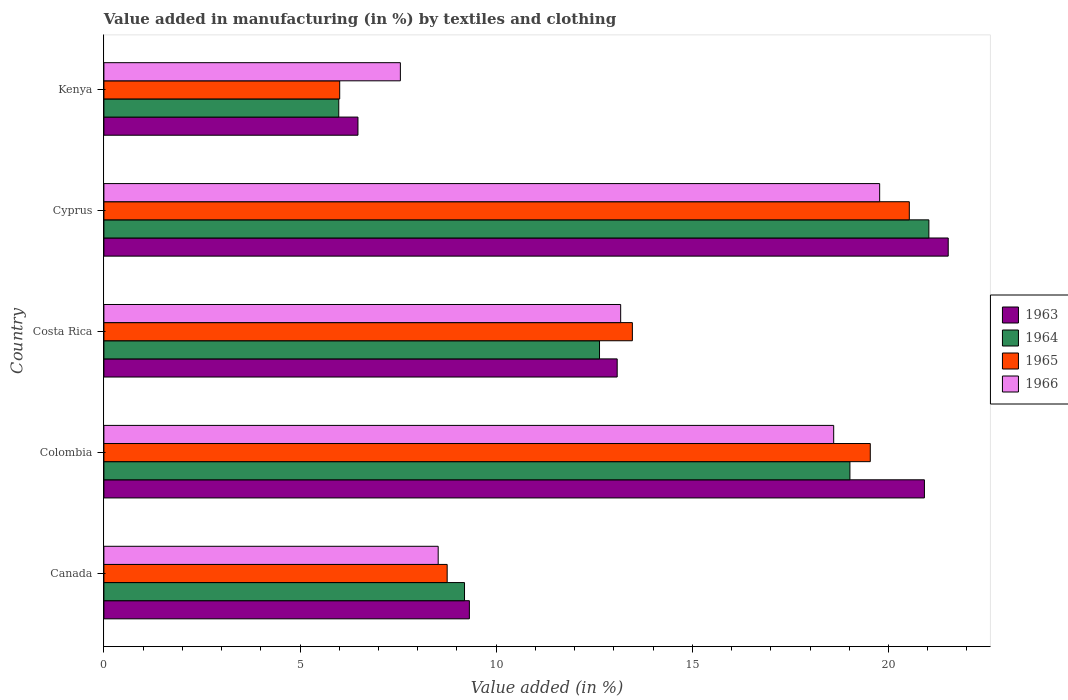What is the percentage of value added in manufacturing by textiles and clothing in 1965 in Cyprus?
Offer a terse response. 20.53. Across all countries, what is the maximum percentage of value added in manufacturing by textiles and clothing in 1964?
Your answer should be compact. 21.03. Across all countries, what is the minimum percentage of value added in manufacturing by textiles and clothing in 1964?
Keep it short and to the point. 5.99. In which country was the percentage of value added in manufacturing by textiles and clothing in 1964 maximum?
Your answer should be compact. Cyprus. In which country was the percentage of value added in manufacturing by textiles and clothing in 1966 minimum?
Ensure brevity in your answer.  Kenya. What is the total percentage of value added in manufacturing by textiles and clothing in 1966 in the graph?
Keep it short and to the point. 67.63. What is the difference between the percentage of value added in manufacturing by textiles and clothing in 1966 in Costa Rica and that in Cyprus?
Offer a very short reply. -6.6. What is the difference between the percentage of value added in manufacturing by textiles and clothing in 1963 in Kenya and the percentage of value added in manufacturing by textiles and clothing in 1965 in Costa Rica?
Your answer should be compact. -7. What is the average percentage of value added in manufacturing by textiles and clothing in 1964 per country?
Make the answer very short. 13.57. What is the difference between the percentage of value added in manufacturing by textiles and clothing in 1963 and percentage of value added in manufacturing by textiles and clothing in 1966 in Canada?
Keep it short and to the point. 0.8. What is the ratio of the percentage of value added in manufacturing by textiles and clothing in 1964 in Cyprus to that in Kenya?
Offer a very short reply. 3.51. What is the difference between the highest and the second highest percentage of value added in manufacturing by textiles and clothing in 1965?
Offer a terse response. 0.99. What is the difference between the highest and the lowest percentage of value added in manufacturing by textiles and clothing in 1964?
Your answer should be compact. 15.04. In how many countries, is the percentage of value added in manufacturing by textiles and clothing in 1963 greater than the average percentage of value added in manufacturing by textiles and clothing in 1963 taken over all countries?
Give a very brief answer. 2. Is the sum of the percentage of value added in manufacturing by textiles and clothing in 1963 in Canada and Cyprus greater than the maximum percentage of value added in manufacturing by textiles and clothing in 1964 across all countries?
Your answer should be compact. Yes. What does the 4th bar from the top in Colombia represents?
Provide a succinct answer. 1963. What does the 3rd bar from the bottom in Cyprus represents?
Offer a terse response. 1965. How many bars are there?
Offer a very short reply. 20. How many countries are there in the graph?
Your response must be concise. 5. Where does the legend appear in the graph?
Your response must be concise. Center right. What is the title of the graph?
Offer a very short reply. Value added in manufacturing (in %) by textiles and clothing. What is the label or title of the X-axis?
Your answer should be compact. Value added (in %). What is the Value added (in %) of 1963 in Canada?
Offer a terse response. 9.32. What is the Value added (in %) of 1964 in Canada?
Provide a succinct answer. 9.19. What is the Value added (in %) of 1965 in Canada?
Offer a very short reply. 8.75. What is the Value added (in %) in 1966 in Canada?
Provide a short and direct response. 8.52. What is the Value added (in %) in 1963 in Colombia?
Offer a terse response. 20.92. What is the Value added (in %) of 1964 in Colombia?
Your response must be concise. 19.02. What is the Value added (in %) in 1965 in Colombia?
Give a very brief answer. 19.54. What is the Value added (in %) of 1966 in Colombia?
Provide a short and direct response. 18.6. What is the Value added (in %) in 1963 in Costa Rica?
Provide a short and direct response. 13.08. What is the Value added (in %) of 1964 in Costa Rica?
Offer a very short reply. 12.63. What is the Value added (in %) in 1965 in Costa Rica?
Ensure brevity in your answer.  13.47. What is the Value added (in %) of 1966 in Costa Rica?
Keep it short and to the point. 13.17. What is the Value added (in %) in 1963 in Cyprus?
Make the answer very short. 21.52. What is the Value added (in %) of 1964 in Cyprus?
Your answer should be very brief. 21.03. What is the Value added (in %) in 1965 in Cyprus?
Provide a short and direct response. 20.53. What is the Value added (in %) in 1966 in Cyprus?
Give a very brief answer. 19.78. What is the Value added (in %) in 1963 in Kenya?
Offer a very short reply. 6.48. What is the Value added (in %) in 1964 in Kenya?
Your answer should be compact. 5.99. What is the Value added (in %) in 1965 in Kenya?
Your answer should be very brief. 6.01. What is the Value added (in %) in 1966 in Kenya?
Ensure brevity in your answer.  7.56. Across all countries, what is the maximum Value added (in %) in 1963?
Give a very brief answer. 21.52. Across all countries, what is the maximum Value added (in %) in 1964?
Keep it short and to the point. 21.03. Across all countries, what is the maximum Value added (in %) in 1965?
Your response must be concise. 20.53. Across all countries, what is the maximum Value added (in %) in 1966?
Provide a short and direct response. 19.78. Across all countries, what is the minimum Value added (in %) of 1963?
Your answer should be compact. 6.48. Across all countries, what is the minimum Value added (in %) in 1964?
Provide a short and direct response. 5.99. Across all countries, what is the minimum Value added (in %) of 1965?
Your answer should be compact. 6.01. Across all countries, what is the minimum Value added (in %) in 1966?
Keep it short and to the point. 7.56. What is the total Value added (in %) of 1963 in the graph?
Offer a very short reply. 71.32. What is the total Value added (in %) of 1964 in the graph?
Your answer should be very brief. 67.86. What is the total Value added (in %) in 1965 in the graph?
Your answer should be very brief. 68.3. What is the total Value added (in %) of 1966 in the graph?
Make the answer very short. 67.63. What is the difference between the Value added (in %) in 1963 in Canada and that in Colombia?
Your response must be concise. -11.6. What is the difference between the Value added (in %) in 1964 in Canada and that in Colombia?
Make the answer very short. -9.82. What is the difference between the Value added (in %) in 1965 in Canada and that in Colombia?
Your response must be concise. -10.79. What is the difference between the Value added (in %) in 1966 in Canada and that in Colombia?
Make the answer very short. -10.08. What is the difference between the Value added (in %) in 1963 in Canada and that in Costa Rica?
Keep it short and to the point. -3.77. What is the difference between the Value added (in %) in 1964 in Canada and that in Costa Rica?
Your answer should be very brief. -3.44. What is the difference between the Value added (in %) in 1965 in Canada and that in Costa Rica?
Your answer should be compact. -4.72. What is the difference between the Value added (in %) of 1966 in Canada and that in Costa Rica?
Keep it short and to the point. -4.65. What is the difference between the Value added (in %) of 1963 in Canada and that in Cyprus?
Your response must be concise. -12.21. What is the difference between the Value added (in %) in 1964 in Canada and that in Cyprus?
Make the answer very short. -11.84. What is the difference between the Value added (in %) of 1965 in Canada and that in Cyprus?
Your response must be concise. -11.78. What is the difference between the Value added (in %) in 1966 in Canada and that in Cyprus?
Make the answer very short. -11.25. What is the difference between the Value added (in %) in 1963 in Canada and that in Kenya?
Provide a short and direct response. 2.84. What is the difference between the Value added (in %) in 1964 in Canada and that in Kenya?
Give a very brief answer. 3.21. What is the difference between the Value added (in %) of 1965 in Canada and that in Kenya?
Provide a succinct answer. 2.74. What is the difference between the Value added (in %) of 1966 in Canada and that in Kenya?
Your response must be concise. 0.96. What is the difference between the Value added (in %) of 1963 in Colombia and that in Costa Rica?
Your response must be concise. 7.83. What is the difference between the Value added (in %) of 1964 in Colombia and that in Costa Rica?
Provide a short and direct response. 6.38. What is the difference between the Value added (in %) in 1965 in Colombia and that in Costa Rica?
Give a very brief answer. 6.06. What is the difference between the Value added (in %) of 1966 in Colombia and that in Costa Rica?
Make the answer very short. 5.43. What is the difference between the Value added (in %) of 1963 in Colombia and that in Cyprus?
Your response must be concise. -0.61. What is the difference between the Value added (in %) of 1964 in Colombia and that in Cyprus?
Make the answer very short. -2.01. What is the difference between the Value added (in %) of 1965 in Colombia and that in Cyprus?
Give a very brief answer. -0.99. What is the difference between the Value added (in %) in 1966 in Colombia and that in Cyprus?
Provide a short and direct response. -1.17. What is the difference between the Value added (in %) of 1963 in Colombia and that in Kenya?
Your answer should be very brief. 14.44. What is the difference between the Value added (in %) in 1964 in Colombia and that in Kenya?
Your answer should be compact. 13.03. What is the difference between the Value added (in %) of 1965 in Colombia and that in Kenya?
Your response must be concise. 13.53. What is the difference between the Value added (in %) of 1966 in Colombia and that in Kenya?
Make the answer very short. 11.05. What is the difference between the Value added (in %) in 1963 in Costa Rica and that in Cyprus?
Keep it short and to the point. -8.44. What is the difference between the Value added (in %) of 1964 in Costa Rica and that in Cyprus?
Your answer should be very brief. -8.4. What is the difference between the Value added (in %) of 1965 in Costa Rica and that in Cyprus?
Make the answer very short. -7.06. What is the difference between the Value added (in %) in 1966 in Costa Rica and that in Cyprus?
Offer a terse response. -6.6. What is the difference between the Value added (in %) in 1963 in Costa Rica and that in Kenya?
Offer a very short reply. 6.61. What is the difference between the Value added (in %) of 1964 in Costa Rica and that in Kenya?
Offer a very short reply. 6.65. What is the difference between the Value added (in %) in 1965 in Costa Rica and that in Kenya?
Provide a succinct answer. 7.46. What is the difference between the Value added (in %) of 1966 in Costa Rica and that in Kenya?
Your answer should be compact. 5.62. What is the difference between the Value added (in %) of 1963 in Cyprus and that in Kenya?
Make the answer very short. 15.05. What is the difference between the Value added (in %) in 1964 in Cyprus and that in Kenya?
Your answer should be compact. 15.04. What is the difference between the Value added (in %) of 1965 in Cyprus and that in Kenya?
Provide a short and direct response. 14.52. What is the difference between the Value added (in %) in 1966 in Cyprus and that in Kenya?
Give a very brief answer. 12.22. What is the difference between the Value added (in %) in 1963 in Canada and the Value added (in %) in 1964 in Colombia?
Make the answer very short. -9.7. What is the difference between the Value added (in %) in 1963 in Canada and the Value added (in %) in 1965 in Colombia?
Make the answer very short. -10.22. What is the difference between the Value added (in %) in 1963 in Canada and the Value added (in %) in 1966 in Colombia?
Your response must be concise. -9.29. What is the difference between the Value added (in %) in 1964 in Canada and the Value added (in %) in 1965 in Colombia?
Your answer should be very brief. -10.34. What is the difference between the Value added (in %) in 1964 in Canada and the Value added (in %) in 1966 in Colombia?
Your answer should be very brief. -9.41. What is the difference between the Value added (in %) in 1965 in Canada and the Value added (in %) in 1966 in Colombia?
Offer a terse response. -9.85. What is the difference between the Value added (in %) of 1963 in Canada and the Value added (in %) of 1964 in Costa Rica?
Your answer should be very brief. -3.32. What is the difference between the Value added (in %) in 1963 in Canada and the Value added (in %) in 1965 in Costa Rica?
Provide a short and direct response. -4.16. What is the difference between the Value added (in %) in 1963 in Canada and the Value added (in %) in 1966 in Costa Rica?
Provide a succinct answer. -3.86. What is the difference between the Value added (in %) in 1964 in Canada and the Value added (in %) in 1965 in Costa Rica?
Provide a short and direct response. -4.28. What is the difference between the Value added (in %) of 1964 in Canada and the Value added (in %) of 1966 in Costa Rica?
Offer a very short reply. -3.98. What is the difference between the Value added (in %) in 1965 in Canada and the Value added (in %) in 1966 in Costa Rica?
Offer a terse response. -4.42. What is the difference between the Value added (in %) in 1963 in Canada and the Value added (in %) in 1964 in Cyprus?
Your answer should be very brief. -11.71. What is the difference between the Value added (in %) in 1963 in Canada and the Value added (in %) in 1965 in Cyprus?
Your answer should be very brief. -11.21. What is the difference between the Value added (in %) in 1963 in Canada and the Value added (in %) in 1966 in Cyprus?
Your answer should be very brief. -10.46. What is the difference between the Value added (in %) of 1964 in Canada and the Value added (in %) of 1965 in Cyprus?
Ensure brevity in your answer.  -11.34. What is the difference between the Value added (in %) of 1964 in Canada and the Value added (in %) of 1966 in Cyprus?
Offer a very short reply. -10.58. What is the difference between the Value added (in %) of 1965 in Canada and the Value added (in %) of 1966 in Cyprus?
Provide a succinct answer. -11.02. What is the difference between the Value added (in %) of 1963 in Canada and the Value added (in %) of 1964 in Kenya?
Offer a very short reply. 3.33. What is the difference between the Value added (in %) of 1963 in Canada and the Value added (in %) of 1965 in Kenya?
Offer a very short reply. 3.31. What is the difference between the Value added (in %) of 1963 in Canada and the Value added (in %) of 1966 in Kenya?
Make the answer very short. 1.76. What is the difference between the Value added (in %) in 1964 in Canada and the Value added (in %) in 1965 in Kenya?
Provide a succinct answer. 3.18. What is the difference between the Value added (in %) in 1964 in Canada and the Value added (in %) in 1966 in Kenya?
Provide a succinct answer. 1.64. What is the difference between the Value added (in %) of 1965 in Canada and the Value added (in %) of 1966 in Kenya?
Offer a very short reply. 1.19. What is the difference between the Value added (in %) of 1963 in Colombia and the Value added (in %) of 1964 in Costa Rica?
Your answer should be very brief. 8.28. What is the difference between the Value added (in %) of 1963 in Colombia and the Value added (in %) of 1965 in Costa Rica?
Provide a short and direct response. 7.44. What is the difference between the Value added (in %) of 1963 in Colombia and the Value added (in %) of 1966 in Costa Rica?
Your answer should be compact. 7.74. What is the difference between the Value added (in %) of 1964 in Colombia and the Value added (in %) of 1965 in Costa Rica?
Keep it short and to the point. 5.55. What is the difference between the Value added (in %) of 1964 in Colombia and the Value added (in %) of 1966 in Costa Rica?
Your response must be concise. 5.84. What is the difference between the Value added (in %) in 1965 in Colombia and the Value added (in %) in 1966 in Costa Rica?
Ensure brevity in your answer.  6.36. What is the difference between the Value added (in %) in 1963 in Colombia and the Value added (in %) in 1964 in Cyprus?
Offer a terse response. -0.11. What is the difference between the Value added (in %) in 1963 in Colombia and the Value added (in %) in 1965 in Cyprus?
Offer a very short reply. 0.39. What is the difference between the Value added (in %) in 1963 in Colombia and the Value added (in %) in 1966 in Cyprus?
Your answer should be compact. 1.14. What is the difference between the Value added (in %) in 1964 in Colombia and the Value added (in %) in 1965 in Cyprus?
Make the answer very short. -1.51. What is the difference between the Value added (in %) in 1964 in Colombia and the Value added (in %) in 1966 in Cyprus?
Provide a succinct answer. -0.76. What is the difference between the Value added (in %) of 1965 in Colombia and the Value added (in %) of 1966 in Cyprus?
Keep it short and to the point. -0.24. What is the difference between the Value added (in %) of 1963 in Colombia and the Value added (in %) of 1964 in Kenya?
Ensure brevity in your answer.  14.93. What is the difference between the Value added (in %) in 1963 in Colombia and the Value added (in %) in 1965 in Kenya?
Offer a terse response. 14.91. What is the difference between the Value added (in %) of 1963 in Colombia and the Value added (in %) of 1966 in Kenya?
Provide a succinct answer. 13.36. What is the difference between the Value added (in %) in 1964 in Colombia and the Value added (in %) in 1965 in Kenya?
Keep it short and to the point. 13.01. What is the difference between the Value added (in %) in 1964 in Colombia and the Value added (in %) in 1966 in Kenya?
Give a very brief answer. 11.46. What is the difference between the Value added (in %) of 1965 in Colombia and the Value added (in %) of 1966 in Kenya?
Offer a very short reply. 11.98. What is the difference between the Value added (in %) of 1963 in Costa Rica and the Value added (in %) of 1964 in Cyprus?
Offer a very short reply. -7.95. What is the difference between the Value added (in %) in 1963 in Costa Rica and the Value added (in %) in 1965 in Cyprus?
Your answer should be very brief. -7.45. What is the difference between the Value added (in %) of 1963 in Costa Rica and the Value added (in %) of 1966 in Cyprus?
Ensure brevity in your answer.  -6.69. What is the difference between the Value added (in %) of 1964 in Costa Rica and the Value added (in %) of 1965 in Cyprus?
Offer a terse response. -7.9. What is the difference between the Value added (in %) in 1964 in Costa Rica and the Value added (in %) in 1966 in Cyprus?
Your answer should be compact. -7.14. What is the difference between the Value added (in %) in 1965 in Costa Rica and the Value added (in %) in 1966 in Cyprus?
Make the answer very short. -6.3. What is the difference between the Value added (in %) in 1963 in Costa Rica and the Value added (in %) in 1964 in Kenya?
Your answer should be very brief. 7.1. What is the difference between the Value added (in %) of 1963 in Costa Rica and the Value added (in %) of 1965 in Kenya?
Your answer should be very brief. 7.07. What is the difference between the Value added (in %) of 1963 in Costa Rica and the Value added (in %) of 1966 in Kenya?
Offer a very short reply. 5.53. What is the difference between the Value added (in %) of 1964 in Costa Rica and the Value added (in %) of 1965 in Kenya?
Offer a very short reply. 6.62. What is the difference between the Value added (in %) of 1964 in Costa Rica and the Value added (in %) of 1966 in Kenya?
Keep it short and to the point. 5.08. What is the difference between the Value added (in %) in 1965 in Costa Rica and the Value added (in %) in 1966 in Kenya?
Offer a very short reply. 5.91. What is the difference between the Value added (in %) in 1963 in Cyprus and the Value added (in %) in 1964 in Kenya?
Ensure brevity in your answer.  15.54. What is the difference between the Value added (in %) of 1963 in Cyprus and the Value added (in %) of 1965 in Kenya?
Ensure brevity in your answer.  15.51. What is the difference between the Value added (in %) of 1963 in Cyprus and the Value added (in %) of 1966 in Kenya?
Your answer should be compact. 13.97. What is the difference between the Value added (in %) of 1964 in Cyprus and the Value added (in %) of 1965 in Kenya?
Your answer should be very brief. 15.02. What is the difference between the Value added (in %) in 1964 in Cyprus and the Value added (in %) in 1966 in Kenya?
Offer a terse response. 13.47. What is the difference between the Value added (in %) of 1965 in Cyprus and the Value added (in %) of 1966 in Kenya?
Offer a terse response. 12.97. What is the average Value added (in %) in 1963 per country?
Provide a short and direct response. 14.26. What is the average Value added (in %) of 1964 per country?
Provide a succinct answer. 13.57. What is the average Value added (in %) of 1965 per country?
Provide a short and direct response. 13.66. What is the average Value added (in %) of 1966 per country?
Provide a succinct answer. 13.53. What is the difference between the Value added (in %) of 1963 and Value added (in %) of 1964 in Canada?
Make the answer very short. 0.12. What is the difference between the Value added (in %) in 1963 and Value added (in %) in 1965 in Canada?
Keep it short and to the point. 0.57. What is the difference between the Value added (in %) in 1963 and Value added (in %) in 1966 in Canada?
Offer a very short reply. 0.8. What is the difference between the Value added (in %) of 1964 and Value added (in %) of 1965 in Canada?
Provide a succinct answer. 0.44. What is the difference between the Value added (in %) of 1964 and Value added (in %) of 1966 in Canada?
Give a very brief answer. 0.67. What is the difference between the Value added (in %) of 1965 and Value added (in %) of 1966 in Canada?
Give a very brief answer. 0.23. What is the difference between the Value added (in %) in 1963 and Value added (in %) in 1964 in Colombia?
Your answer should be compact. 1.9. What is the difference between the Value added (in %) of 1963 and Value added (in %) of 1965 in Colombia?
Your answer should be very brief. 1.38. What is the difference between the Value added (in %) of 1963 and Value added (in %) of 1966 in Colombia?
Offer a terse response. 2.31. What is the difference between the Value added (in %) of 1964 and Value added (in %) of 1965 in Colombia?
Provide a succinct answer. -0.52. What is the difference between the Value added (in %) of 1964 and Value added (in %) of 1966 in Colombia?
Give a very brief answer. 0.41. What is the difference between the Value added (in %) in 1965 and Value added (in %) in 1966 in Colombia?
Provide a short and direct response. 0.93. What is the difference between the Value added (in %) of 1963 and Value added (in %) of 1964 in Costa Rica?
Ensure brevity in your answer.  0.45. What is the difference between the Value added (in %) of 1963 and Value added (in %) of 1965 in Costa Rica?
Provide a succinct answer. -0.39. What is the difference between the Value added (in %) of 1963 and Value added (in %) of 1966 in Costa Rica?
Your answer should be very brief. -0.09. What is the difference between the Value added (in %) in 1964 and Value added (in %) in 1965 in Costa Rica?
Provide a short and direct response. -0.84. What is the difference between the Value added (in %) of 1964 and Value added (in %) of 1966 in Costa Rica?
Offer a terse response. -0.54. What is the difference between the Value added (in %) in 1965 and Value added (in %) in 1966 in Costa Rica?
Give a very brief answer. 0.3. What is the difference between the Value added (in %) of 1963 and Value added (in %) of 1964 in Cyprus?
Provide a succinct answer. 0.49. What is the difference between the Value added (in %) in 1963 and Value added (in %) in 1965 in Cyprus?
Your answer should be compact. 0.99. What is the difference between the Value added (in %) of 1963 and Value added (in %) of 1966 in Cyprus?
Offer a terse response. 1.75. What is the difference between the Value added (in %) in 1964 and Value added (in %) in 1965 in Cyprus?
Provide a succinct answer. 0.5. What is the difference between the Value added (in %) of 1964 and Value added (in %) of 1966 in Cyprus?
Provide a short and direct response. 1.25. What is the difference between the Value added (in %) in 1965 and Value added (in %) in 1966 in Cyprus?
Provide a short and direct response. 0.76. What is the difference between the Value added (in %) of 1963 and Value added (in %) of 1964 in Kenya?
Offer a terse response. 0.49. What is the difference between the Value added (in %) in 1963 and Value added (in %) in 1965 in Kenya?
Keep it short and to the point. 0.47. What is the difference between the Value added (in %) in 1963 and Value added (in %) in 1966 in Kenya?
Ensure brevity in your answer.  -1.08. What is the difference between the Value added (in %) in 1964 and Value added (in %) in 1965 in Kenya?
Make the answer very short. -0.02. What is the difference between the Value added (in %) of 1964 and Value added (in %) of 1966 in Kenya?
Ensure brevity in your answer.  -1.57. What is the difference between the Value added (in %) of 1965 and Value added (in %) of 1966 in Kenya?
Your response must be concise. -1.55. What is the ratio of the Value added (in %) of 1963 in Canada to that in Colombia?
Offer a terse response. 0.45. What is the ratio of the Value added (in %) in 1964 in Canada to that in Colombia?
Keep it short and to the point. 0.48. What is the ratio of the Value added (in %) in 1965 in Canada to that in Colombia?
Give a very brief answer. 0.45. What is the ratio of the Value added (in %) of 1966 in Canada to that in Colombia?
Offer a very short reply. 0.46. What is the ratio of the Value added (in %) in 1963 in Canada to that in Costa Rica?
Offer a terse response. 0.71. What is the ratio of the Value added (in %) of 1964 in Canada to that in Costa Rica?
Your response must be concise. 0.73. What is the ratio of the Value added (in %) in 1965 in Canada to that in Costa Rica?
Your answer should be very brief. 0.65. What is the ratio of the Value added (in %) of 1966 in Canada to that in Costa Rica?
Give a very brief answer. 0.65. What is the ratio of the Value added (in %) of 1963 in Canada to that in Cyprus?
Ensure brevity in your answer.  0.43. What is the ratio of the Value added (in %) of 1964 in Canada to that in Cyprus?
Provide a short and direct response. 0.44. What is the ratio of the Value added (in %) of 1965 in Canada to that in Cyprus?
Your answer should be compact. 0.43. What is the ratio of the Value added (in %) in 1966 in Canada to that in Cyprus?
Offer a very short reply. 0.43. What is the ratio of the Value added (in %) in 1963 in Canada to that in Kenya?
Ensure brevity in your answer.  1.44. What is the ratio of the Value added (in %) of 1964 in Canada to that in Kenya?
Your response must be concise. 1.54. What is the ratio of the Value added (in %) in 1965 in Canada to that in Kenya?
Offer a very short reply. 1.46. What is the ratio of the Value added (in %) of 1966 in Canada to that in Kenya?
Offer a terse response. 1.13. What is the ratio of the Value added (in %) of 1963 in Colombia to that in Costa Rica?
Provide a short and direct response. 1.6. What is the ratio of the Value added (in %) in 1964 in Colombia to that in Costa Rica?
Your answer should be compact. 1.51. What is the ratio of the Value added (in %) in 1965 in Colombia to that in Costa Rica?
Keep it short and to the point. 1.45. What is the ratio of the Value added (in %) of 1966 in Colombia to that in Costa Rica?
Offer a very short reply. 1.41. What is the ratio of the Value added (in %) of 1963 in Colombia to that in Cyprus?
Provide a short and direct response. 0.97. What is the ratio of the Value added (in %) of 1964 in Colombia to that in Cyprus?
Provide a short and direct response. 0.9. What is the ratio of the Value added (in %) in 1965 in Colombia to that in Cyprus?
Offer a terse response. 0.95. What is the ratio of the Value added (in %) in 1966 in Colombia to that in Cyprus?
Ensure brevity in your answer.  0.94. What is the ratio of the Value added (in %) in 1963 in Colombia to that in Kenya?
Provide a succinct answer. 3.23. What is the ratio of the Value added (in %) of 1964 in Colombia to that in Kenya?
Ensure brevity in your answer.  3.18. What is the ratio of the Value added (in %) in 1966 in Colombia to that in Kenya?
Keep it short and to the point. 2.46. What is the ratio of the Value added (in %) in 1963 in Costa Rica to that in Cyprus?
Offer a very short reply. 0.61. What is the ratio of the Value added (in %) of 1964 in Costa Rica to that in Cyprus?
Offer a very short reply. 0.6. What is the ratio of the Value added (in %) of 1965 in Costa Rica to that in Cyprus?
Make the answer very short. 0.66. What is the ratio of the Value added (in %) in 1966 in Costa Rica to that in Cyprus?
Your answer should be compact. 0.67. What is the ratio of the Value added (in %) of 1963 in Costa Rica to that in Kenya?
Offer a very short reply. 2.02. What is the ratio of the Value added (in %) of 1964 in Costa Rica to that in Kenya?
Your answer should be compact. 2.11. What is the ratio of the Value added (in %) in 1965 in Costa Rica to that in Kenya?
Your answer should be compact. 2.24. What is the ratio of the Value added (in %) in 1966 in Costa Rica to that in Kenya?
Your response must be concise. 1.74. What is the ratio of the Value added (in %) of 1963 in Cyprus to that in Kenya?
Your answer should be very brief. 3.32. What is the ratio of the Value added (in %) of 1964 in Cyprus to that in Kenya?
Provide a short and direct response. 3.51. What is the ratio of the Value added (in %) of 1965 in Cyprus to that in Kenya?
Provide a succinct answer. 3.42. What is the ratio of the Value added (in %) in 1966 in Cyprus to that in Kenya?
Your answer should be very brief. 2.62. What is the difference between the highest and the second highest Value added (in %) of 1963?
Give a very brief answer. 0.61. What is the difference between the highest and the second highest Value added (in %) of 1964?
Ensure brevity in your answer.  2.01. What is the difference between the highest and the second highest Value added (in %) in 1966?
Ensure brevity in your answer.  1.17. What is the difference between the highest and the lowest Value added (in %) in 1963?
Make the answer very short. 15.05. What is the difference between the highest and the lowest Value added (in %) in 1964?
Offer a very short reply. 15.04. What is the difference between the highest and the lowest Value added (in %) in 1965?
Ensure brevity in your answer.  14.52. What is the difference between the highest and the lowest Value added (in %) in 1966?
Make the answer very short. 12.22. 